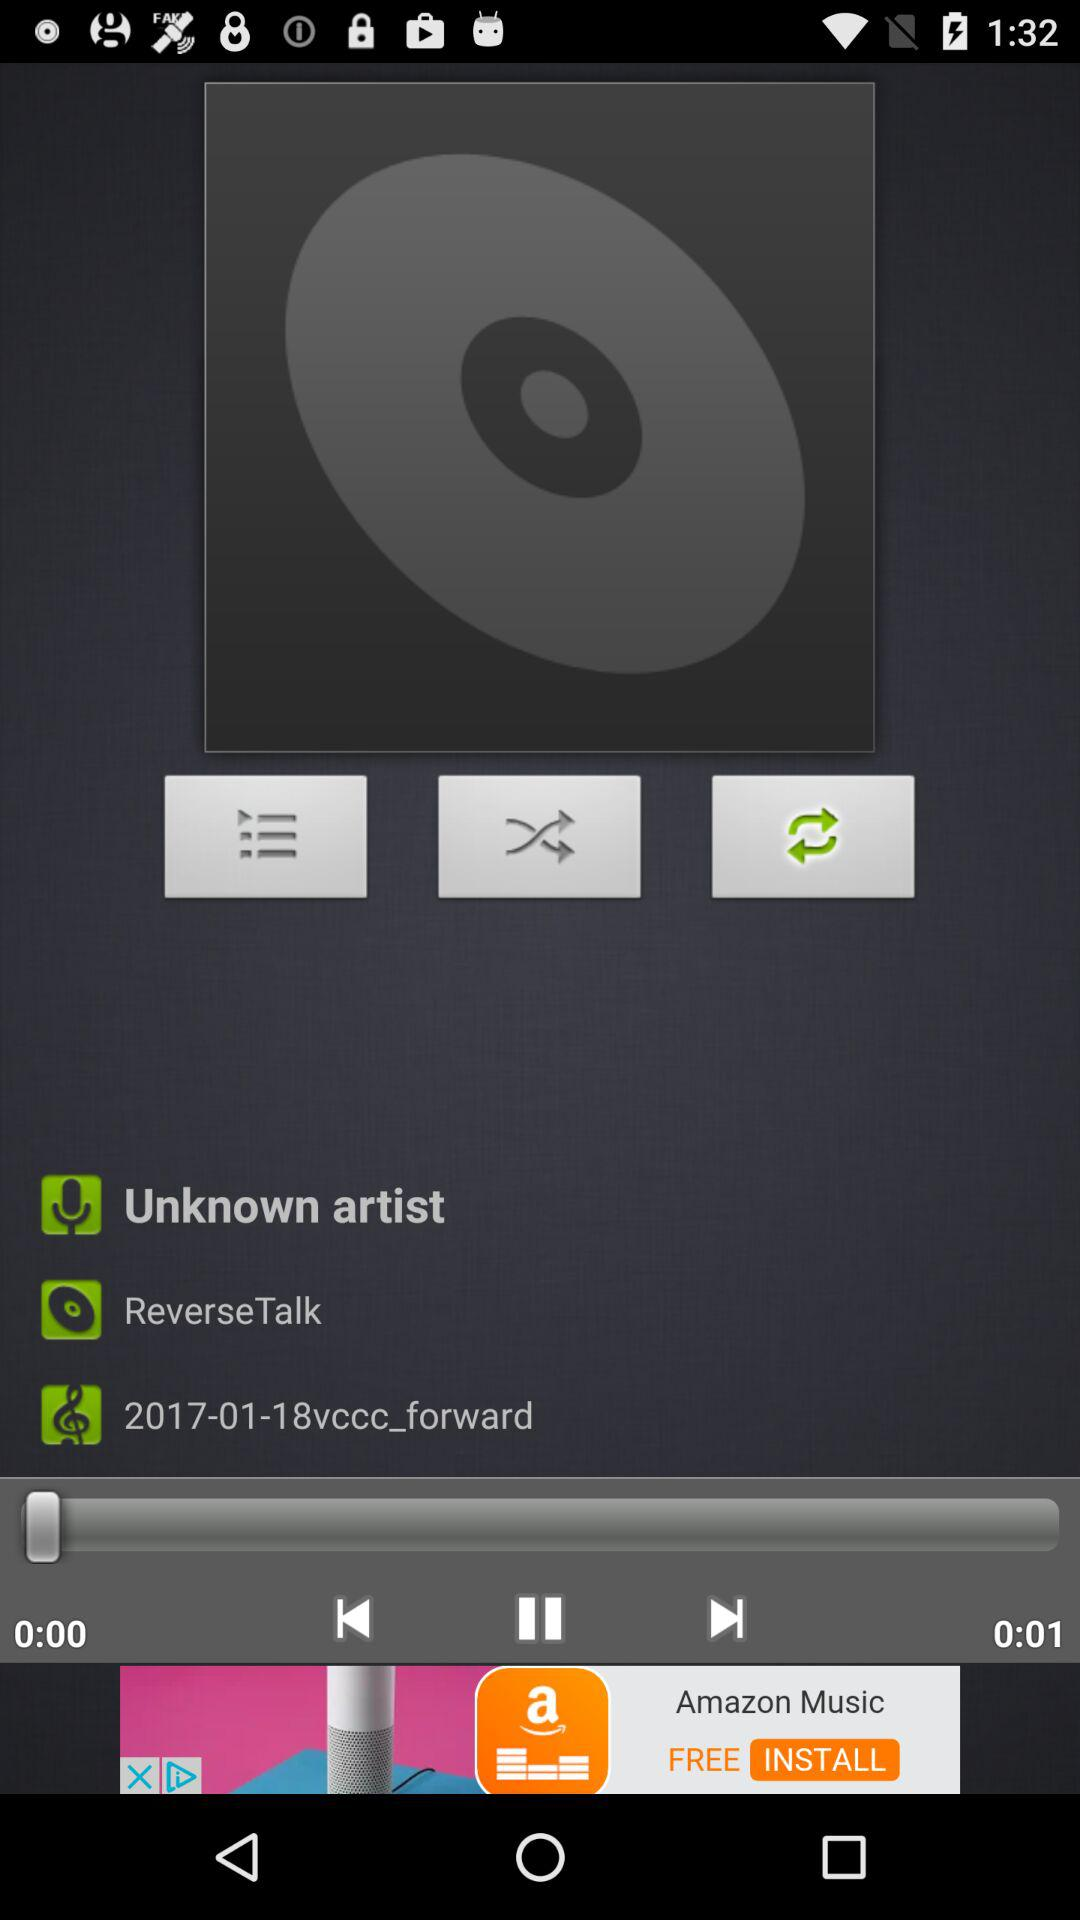What is the duration of the song? The duration of the song is 1 second. 